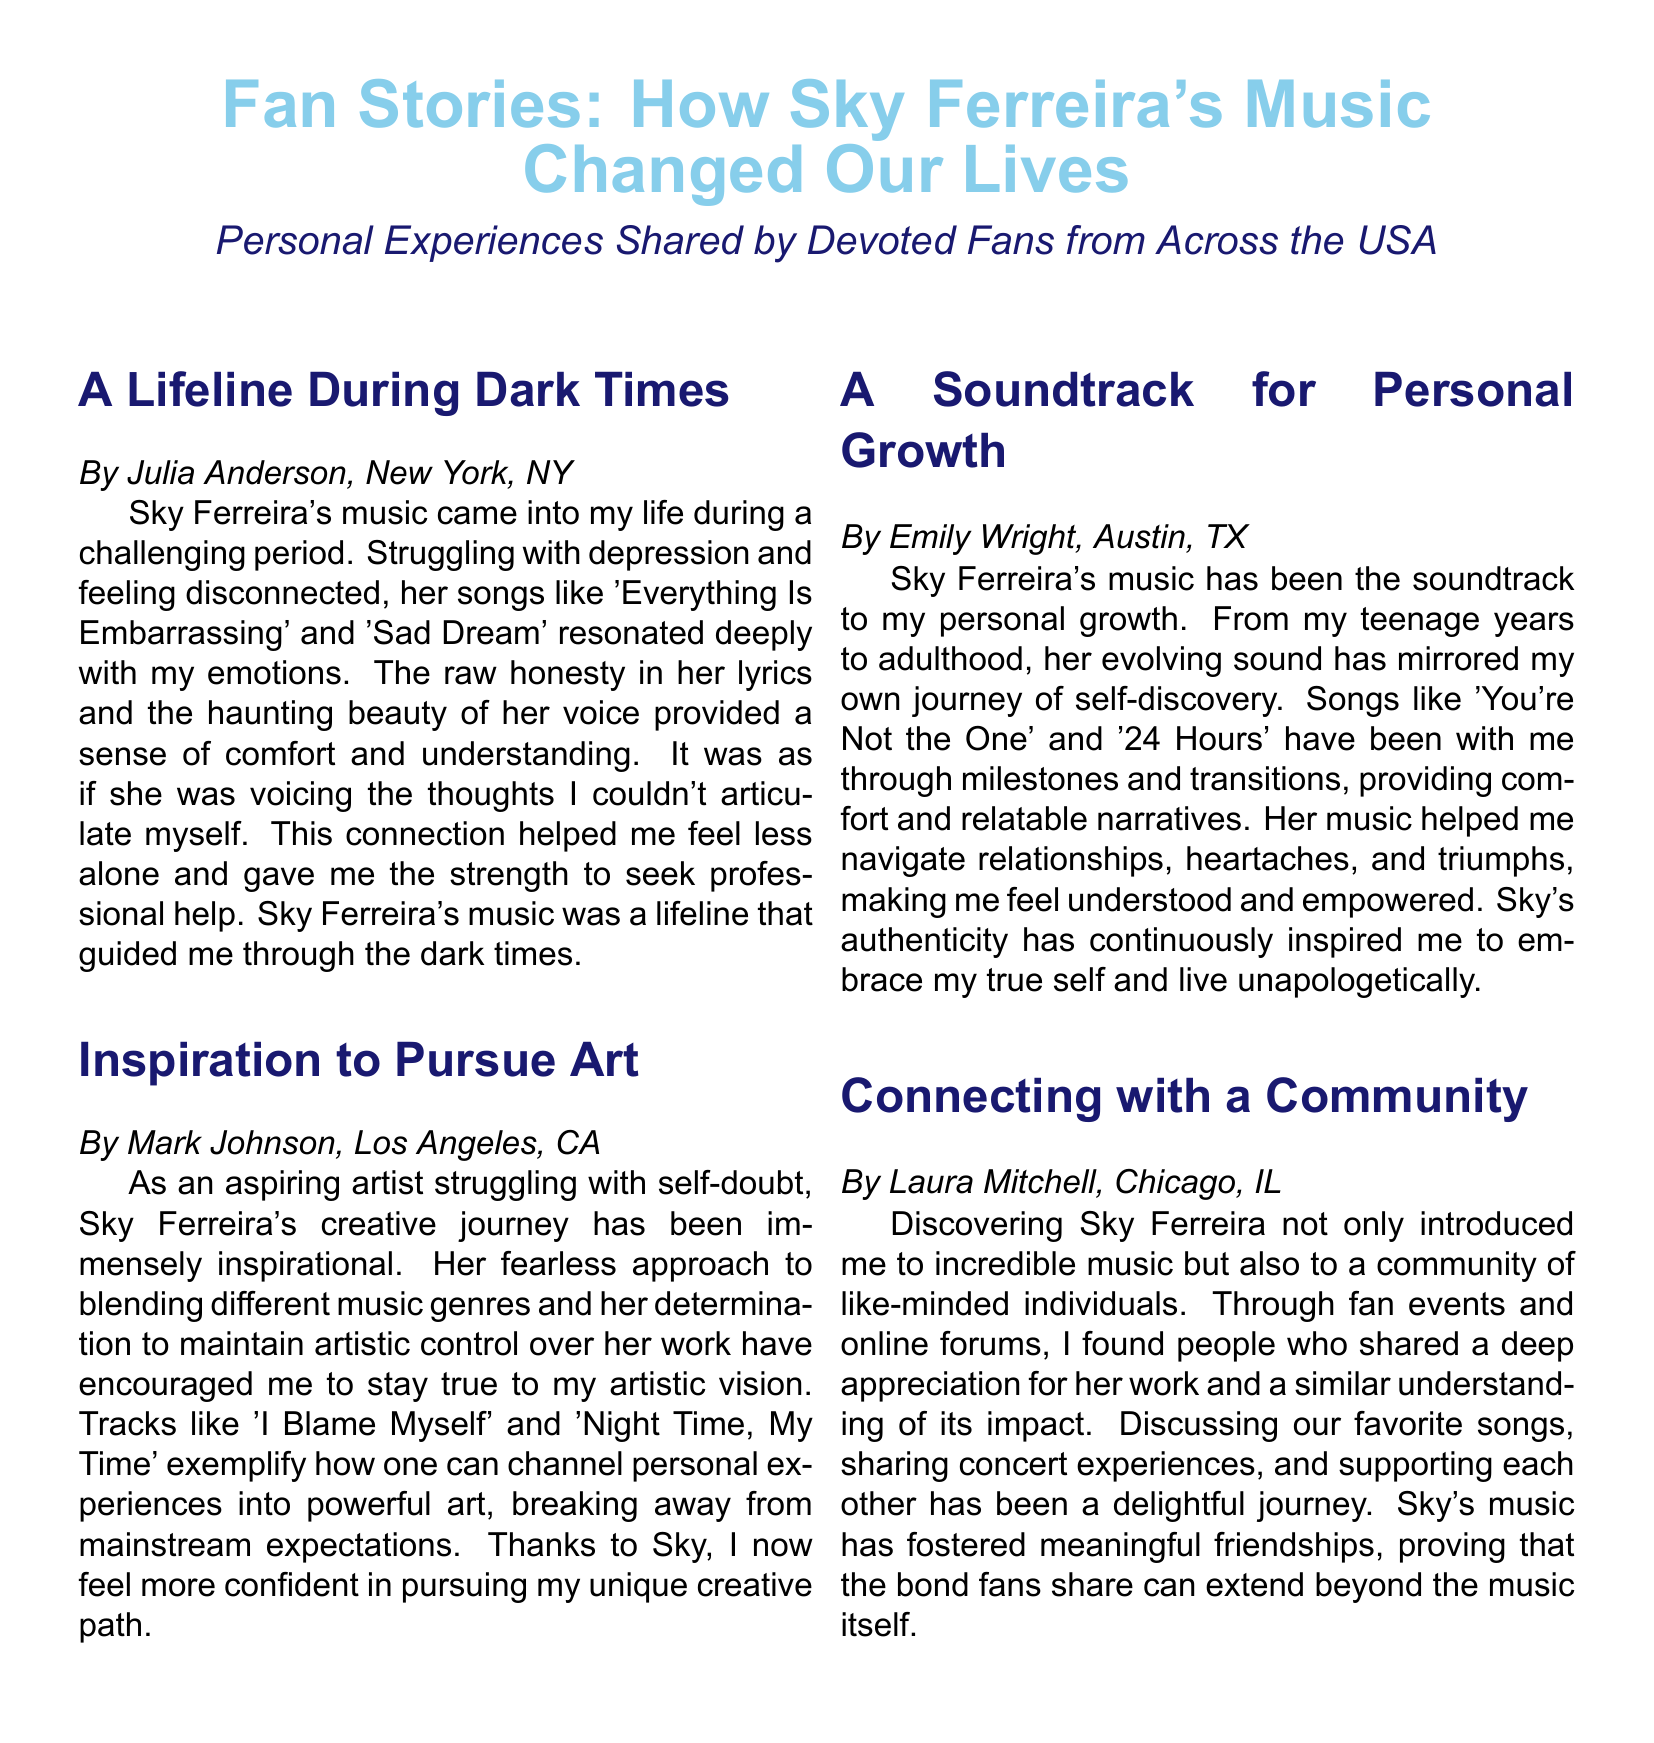What is the title of the document? The title of the document is found in the opening section, highlighting the central theme, which is "Fan Stories: How Sky Ferreira's Music Changed Our Lives."
Answer: Fan Stories: How Sky Ferreira's Music Changed Our Lives Who wrote the story about personal growth? The author of the story about personal growth is identified in their section, which mentions Emily Wright.
Answer: Emily Wright Which song helped Julia Anderson feel less alone? Julia Anderson specifically mentions the song 'Everything Is Embarrassing' as providing comfort during her challenging times.
Answer: Everything Is Embarrassing What city is Mark Johnson from? Mark Johnson's location is stated in the introduction of his story, indicating he is from Los Angeles, CA.
Answer: Los Angeles, CA How has Sky's music impacted Emily Wright? Emily Wright describes her experience with Sky's music as a soundtrack to her personal growth, highlighting its influence on her journey.
Answer: Soundtrack to personal growth Which concept did Laura Mitchell emphasize in her story? Laura Mitchell focused on the idea of community formed around shared appreciation for Sky's music and the connections established among fans.
Answer: Connecting with a community What genre approach inspired Mark Johnson? Mark Johnson mentions Sky Ferreira's approach to blending different music genres as an inspiration for his own artistic path.
Answer: Blending different music genres What recurring theme is apparent in the stories shared? A recurring theme in the stories highlights the impact of Sky Ferreira's music on emotional well-being and personal development across various contexts.
Answer: Emotional well-being and personal development 